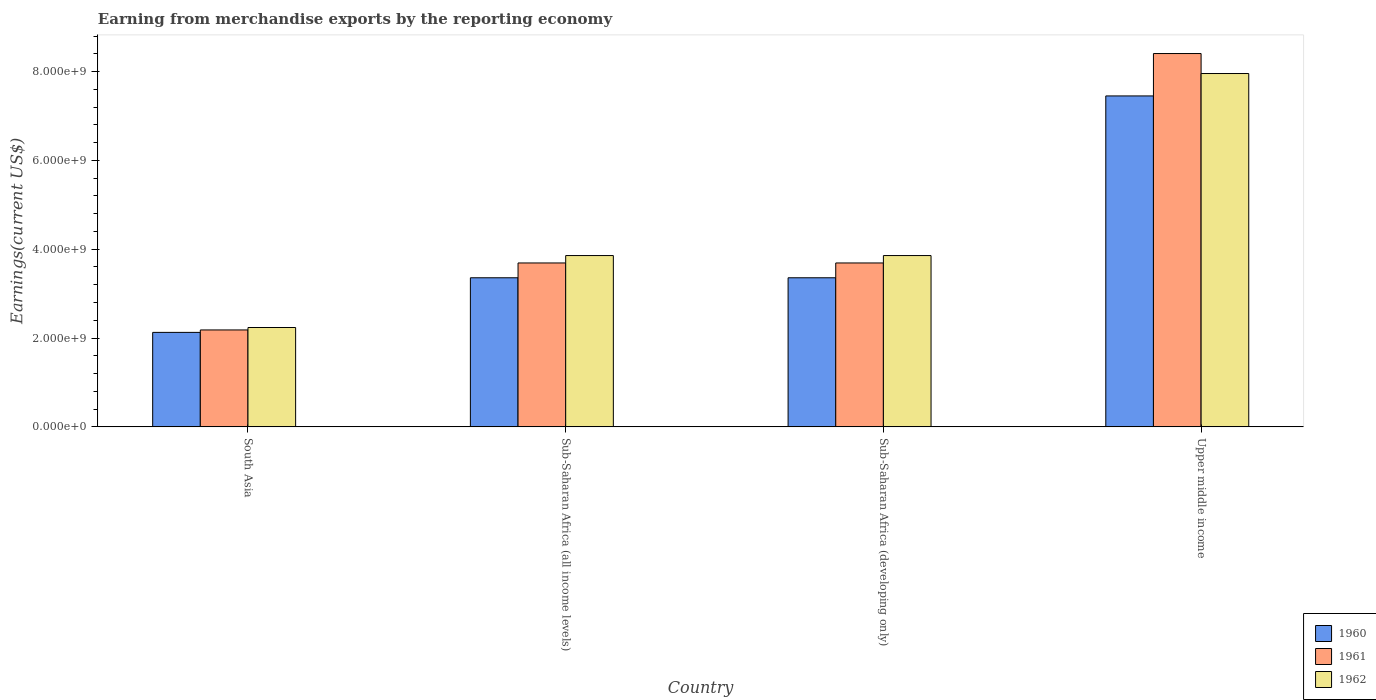How many groups of bars are there?
Give a very brief answer. 4. Are the number of bars per tick equal to the number of legend labels?
Provide a succinct answer. Yes. How many bars are there on the 3rd tick from the right?
Give a very brief answer. 3. What is the label of the 1st group of bars from the left?
Offer a terse response. South Asia. What is the amount earned from merchandise exports in 1960 in South Asia?
Keep it short and to the point. 2.13e+09. Across all countries, what is the maximum amount earned from merchandise exports in 1961?
Keep it short and to the point. 8.41e+09. Across all countries, what is the minimum amount earned from merchandise exports in 1962?
Your response must be concise. 2.24e+09. In which country was the amount earned from merchandise exports in 1962 maximum?
Ensure brevity in your answer.  Upper middle income. In which country was the amount earned from merchandise exports in 1960 minimum?
Ensure brevity in your answer.  South Asia. What is the total amount earned from merchandise exports in 1960 in the graph?
Make the answer very short. 1.63e+1. What is the difference between the amount earned from merchandise exports in 1962 in South Asia and that in Sub-Saharan Africa (developing only)?
Provide a succinct answer. -1.62e+09. What is the difference between the amount earned from merchandise exports in 1962 in Sub-Saharan Africa (developing only) and the amount earned from merchandise exports in 1961 in Upper middle income?
Ensure brevity in your answer.  -4.55e+09. What is the average amount earned from merchandise exports in 1960 per country?
Your answer should be compact. 4.07e+09. What is the difference between the amount earned from merchandise exports of/in 1960 and amount earned from merchandise exports of/in 1961 in South Asia?
Ensure brevity in your answer.  -5.49e+07. In how many countries, is the amount earned from merchandise exports in 1961 greater than 1200000000 US$?
Keep it short and to the point. 4. Is the amount earned from merchandise exports in 1961 in Sub-Saharan Africa (all income levels) less than that in Upper middle income?
Provide a succinct answer. Yes. What is the difference between the highest and the second highest amount earned from merchandise exports in 1962?
Offer a very short reply. 4.10e+09. What is the difference between the highest and the lowest amount earned from merchandise exports in 1961?
Keep it short and to the point. 6.22e+09. What does the 1st bar from the left in South Asia represents?
Offer a very short reply. 1960. How many countries are there in the graph?
Ensure brevity in your answer.  4. Are the values on the major ticks of Y-axis written in scientific E-notation?
Keep it short and to the point. Yes. Does the graph contain any zero values?
Your response must be concise. No. Where does the legend appear in the graph?
Provide a short and direct response. Bottom right. How many legend labels are there?
Offer a very short reply. 3. How are the legend labels stacked?
Offer a very short reply. Vertical. What is the title of the graph?
Offer a terse response. Earning from merchandise exports by the reporting economy. What is the label or title of the Y-axis?
Your response must be concise. Earnings(current US$). What is the Earnings(current US$) in 1960 in South Asia?
Your answer should be very brief. 2.13e+09. What is the Earnings(current US$) of 1961 in South Asia?
Give a very brief answer. 2.18e+09. What is the Earnings(current US$) in 1962 in South Asia?
Your answer should be very brief. 2.24e+09. What is the Earnings(current US$) of 1960 in Sub-Saharan Africa (all income levels)?
Your answer should be compact. 3.36e+09. What is the Earnings(current US$) of 1961 in Sub-Saharan Africa (all income levels)?
Keep it short and to the point. 3.69e+09. What is the Earnings(current US$) in 1962 in Sub-Saharan Africa (all income levels)?
Provide a short and direct response. 3.86e+09. What is the Earnings(current US$) of 1960 in Sub-Saharan Africa (developing only)?
Keep it short and to the point. 3.36e+09. What is the Earnings(current US$) in 1961 in Sub-Saharan Africa (developing only)?
Your answer should be compact. 3.69e+09. What is the Earnings(current US$) of 1962 in Sub-Saharan Africa (developing only)?
Offer a very short reply. 3.86e+09. What is the Earnings(current US$) of 1960 in Upper middle income?
Your answer should be very brief. 7.45e+09. What is the Earnings(current US$) of 1961 in Upper middle income?
Give a very brief answer. 8.41e+09. What is the Earnings(current US$) in 1962 in Upper middle income?
Make the answer very short. 7.96e+09. Across all countries, what is the maximum Earnings(current US$) of 1960?
Make the answer very short. 7.45e+09. Across all countries, what is the maximum Earnings(current US$) in 1961?
Your answer should be compact. 8.41e+09. Across all countries, what is the maximum Earnings(current US$) in 1962?
Offer a very short reply. 7.96e+09. Across all countries, what is the minimum Earnings(current US$) in 1960?
Offer a very short reply. 2.13e+09. Across all countries, what is the minimum Earnings(current US$) of 1961?
Ensure brevity in your answer.  2.18e+09. Across all countries, what is the minimum Earnings(current US$) of 1962?
Give a very brief answer. 2.24e+09. What is the total Earnings(current US$) of 1960 in the graph?
Provide a succinct answer. 1.63e+1. What is the total Earnings(current US$) of 1961 in the graph?
Provide a short and direct response. 1.80e+1. What is the total Earnings(current US$) in 1962 in the graph?
Provide a succinct answer. 1.79e+1. What is the difference between the Earnings(current US$) in 1960 in South Asia and that in Sub-Saharan Africa (all income levels)?
Your response must be concise. -1.23e+09. What is the difference between the Earnings(current US$) in 1961 in South Asia and that in Sub-Saharan Africa (all income levels)?
Provide a short and direct response. -1.51e+09. What is the difference between the Earnings(current US$) in 1962 in South Asia and that in Sub-Saharan Africa (all income levels)?
Offer a very short reply. -1.62e+09. What is the difference between the Earnings(current US$) of 1960 in South Asia and that in Sub-Saharan Africa (developing only)?
Provide a short and direct response. -1.23e+09. What is the difference between the Earnings(current US$) in 1961 in South Asia and that in Sub-Saharan Africa (developing only)?
Offer a very short reply. -1.51e+09. What is the difference between the Earnings(current US$) in 1962 in South Asia and that in Sub-Saharan Africa (developing only)?
Your answer should be compact. -1.62e+09. What is the difference between the Earnings(current US$) of 1960 in South Asia and that in Upper middle income?
Your answer should be compact. -5.32e+09. What is the difference between the Earnings(current US$) in 1961 in South Asia and that in Upper middle income?
Keep it short and to the point. -6.22e+09. What is the difference between the Earnings(current US$) in 1962 in South Asia and that in Upper middle income?
Provide a short and direct response. -5.72e+09. What is the difference between the Earnings(current US$) of 1961 in Sub-Saharan Africa (all income levels) and that in Sub-Saharan Africa (developing only)?
Ensure brevity in your answer.  0. What is the difference between the Earnings(current US$) in 1960 in Sub-Saharan Africa (all income levels) and that in Upper middle income?
Keep it short and to the point. -4.09e+09. What is the difference between the Earnings(current US$) in 1961 in Sub-Saharan Africa (all income levels) and that in Upper middle income?
Offer a terse response. -4.72e+09. What is the difference between the Earnings(current US$) of 1962 in Sub-Saharan Africa (all income levels) and that in Upper middle income?
Your response must be concise. -4.10e+09. What is the difference between the Earnings(current US$) of 1960 in Sub-Saharan Africa (developing only) and that in Upper middle income?
Ensure brevity in your answer.  -4.09e+09. What is the difference between the Earnings(current US$) of 1961 in Sub-Saharan Africa (developing only) and that in Upper middle income?
Make the answer very short. -4.72e+09. What is the difference between the Earnings(current US$) in 1962 in Sub-Saharan Africa (developing only) and that in Upper middle income?
Your answer should be compact. -4.10e+09. What is the difference between the Earnings(current US$) of 1960 in South Asia and the Earnings(current US$) of 1961 in Sub-Saharan Africa (all income levels)?
Provide a short and direct response. -1.56e+09. What is the difference between the Earnings(current US$) of 1960 in South Asia and the Earnings(current US$) of 1962 in Sub-Saharan Africa (all income levels)?
Your answer should be compact. -1.73e+09. What is the difference between the Earnings(current US$) in 1961 in South Asia and the Earnings(current US$) in 1962 in Sub-Saharan Africa (all income levels)?
Your answer should be very brief. -1.67e+09. What is the difference between the Earnings(current US$) of 1960 in South Asia and the Earnings(current US$) of 1961 in Sub-Saharan Africa (developing only)?
Your response must be concise. -1.56e+09. What is the difference between the Earnings(current US$) of 1960 in South Asia and the Earnings(current US$) of 1962 in Sub-Saharan Africa (developing only)?
Provide a succinct answer. -1.73e+09. What is the difference between the Earnings(current US$) in 1961 in South Asia and the Earnings(current US$) in 1962 in Sub-Saharan Africa (developing only)?
Your answer should be compact. -1.67e+09. What is the difference between the Earnings(current US$) of 1960 in South Asia and the Earnings(current US$) of 1961 in Upper middle income?
Give a very brief answer. -6.28e+09. What is the difference between the Earnings(current US$) in 1960 in South Asia and the Earnings(current US$) in 1962 in Upper middle income?
Your answer should be compact. -5.83e+09. What is the difference between the Earnings(current US$) of 1961 in South Asia and the Earnings(current US$) of 1962 in Upper middle income?
Your response must be concise. -5.77e+09. What is the difference between the Earnings(current US$) in 1960 in Sub-Saharan Africa (all income levels) and the Earnings(current US$) in 1961 in Sub-Saharan Africa (developing only)?
Give a very brief answer. -3.33e+08. What is the difference between the Earnings(current US$) in 1960 in Sub-Saharan Africa (all income levels) and the Earnings(current US$) in 1962 in Sub-Saharan Africa (developing only)?
Provide a succinct answer. -5.00e+08. What is the difference between the Earnings(current US$) in 1961 in Sub-Saharan Africa (all income levels) and the Earnings(current US$) in 1962 in Sub-Saharan Africa (developing only)?
Provide a succinct answer. -1.67e+08. What is the difference between the Earnings(current US$) of 1960 in Sub-Saharan Africa (all income levels) and the Earnings(current US$) of 1961 in Upper middle income?
Keep it short and to the point. -5.05e+09. What is the difference between the Earnings(current US$) of 1960 in Sub-Saharan Africa (all income levels) and the Earnings(current US$) of 1962 in Upper middle income?
Keep it short and to the point. -4.60e+09. What is the difference between the Earnings(current US$) of 1961 in Sub-Saharan Africa (all income levels) and the Earnings(current US$) of 1962 in Upper middle income?
Offer a terse response. -4.27e+09. What is the difference between the Earnings(current US$) in 1960 in Sub-Saharan Africa (developing only) and the Earnings(current US$) in 1961 in Upper middle income?
Offer a very short reply. -5.05e+09. What is the difference between the Earnings(current US$) in 1960 in Sub-Saharan Africa (developing only) and the Earnings(current US$) in 1962 in Upper middle income?
Ensure brevity in your answer.  -4.60e+09. What is the difference between the Earnings(current US$) in 1961 in Sub-Saharan Africa (developing only) and the Earnings(current US$) in 1962 in Upper middle income?
Your response must be concise. -4.27e+09. What is the average Earnings(current US$) of 1960 per country?
Give a very brief answer. 4.07e+09. What is the average Earnings(current US$) in 1961 per country?
Your answer should be very brief. 4.49e+09. What is the average Earnings(current US$) of 1962 per country?
Your answer should be very brief. 4.48e+09. What is the difference between the Earnings(current US$) of 1960 and Earnings(current US$) of 1961 in South Asia?
Your answer should be compact. -5.49e+07. What is the difference between the Earnings(current US$) of 1960 and Earnings(current US$) of 1962 in South Asia?
Ensure brevity in your answer.  -1.10e+08. What is the difference between the Earnings(current US$) of 1961 and Earnings(current US$) of 1962 in South Asia?
Offer a very short reply. -5.48e+07. What is the difference between the Earnings(current US$) in 1960 and Earnings(current US$) in 1961 in Sub-Saharan Africa (all income levels)?
Make the answer very short. -3.33e+08. What is the difference between the Earnings(current US$) in 1960 and Earnings(current US$) in 1962 in Sub-Saharan Africa (all income levels)?
Keep it short and to the point. -5.00e+08. What is the difference between the Earnings(current US$) in 1961 and Earnings(current US$) in 1962 in Sub-Saharan Africa (all income levels)?
Ensure brevity in your answer.  -1.67e+08. What is the difference between the Earnings(current US$) of 1960 and Earnings(current US$) of 1961 in Sub-Saharan Africa (developing only)?
Keep it short and to the point. -3.33e+08. What is the difference between the Earnings(current US$) of 1960 and Earnings(current US$) of 1962 in Sub-Saharan Africa (developing only)?
Provide a short and direct response. -5.00e+08. What is the difference between the Earnings(current US$) of 1961 and Earnings(current US$) of 1962 in Sub-Saharan Africa (developing only)?
Your answer should be very brief. -1.67e+08. What is the difference between the Earnings(current US$) of 1960 and Earnings(current US$) of 1961 in Upper middle income?
Your answer should be very brief. -9.55e+08. What is the difference between the Earnings(current US$) in 1960 and Earnings(current US$) in 1962 in Upper middle income?
Offer a terse response. -5.05e+08. What is the difference between the Earnings(current US$) in 1961 and Earnings(current US$) in 1962 in Upper middle income?
Offer a terse response. 4.50e+08. What is the ratio of the Earnings(current US$) in 1960 in South Asia to that in Sub-Saharan Africa (all income levels)?
Your answer should be very brief. 0.63. What is the ratio of the Earnings(current US$) in 1961 in South Asia to that in Sub-Saharan Africa (all income levels)?
Your response must be concise. 0.59. What is the ratio of the Earnings(current US$) in 1962 in South Asia to that in Sub-Saharan Africa (all income levels)?
Keep it short and to the point. 0.58. What is the ratio of the Earnings(current US$) in 1960 in South Asia to that in Sub-Saharan Africa (developing only)?
Your answer should be very brief. 0.63. What is the ratio of the Earnings(current US$) of 1961 in South Asia to that in Sub-Saharan Africa (developing only)?
Give a very brief answer. 0.59. What is the ratio of the Earnings(current US$) in 1962 in South Asia to that in Sub-Saharan Africa (developing only)?
Provide a succinct answer. 0.58. What is the ratio of the Earnings(current US$) in 1960 in South Asia to that in Upper middle income?
Keep it short and to the point. 0.29. What is the ratio of the Earnings(current US$) in 1961 in South Asia to that in Upper middle income?
Keep it short and to the point. 0.26. What is the ratio of the Earnings(current US$) in 1962 in South Asia to that in Upper middle income?
Offer a very short reply. 0.28. What is the ratio of the Earnings(current US$) of 1960 in Sub-Saharan Africa (all income levels) to that in Sub-Saharan Africa (developing only)?
Provide a succinct answer. 1. What is the ratio of the Earnings(current US$) in 1961 in Sub-Saharan Africa (all income levels) to that in Sub-Saharan Africa (developing only)?
Provide a short and direct response. 1. What is the ratio of the Earnings(current US$) in 1962 in Sub-Saharan Africa (all income levels) to that in Sub-Saharan Africa (developing only)?
Keep it short and to the point. 1. What is the ratio of the Earnings(current US$) of 1960 in Sub-Saharan Africa (all income levels) to that in Upper middle income?
Your answer should be very brief. 0.45. What is the ratio of the Earnings(current US$) in 1961 in Sub-Saharan Africa (all income levels) to that in Upper middle income?
Provide a short and direct response. 0.44. What is the ratio of the Earnings(current US$) of 1962 in Sub-Saharan Africa (all income levels) to that in Upper middle income?
Ensure brevity in your answer.  0.48. What is the ratio of the Earnings(current US$) in 1960 in Sub-Saharan Africa (developing only) to that in Upper middle income?
Keep it short and to the point. 0.45. What is the ratio of the Earnings(current US$) of 1961 in Sub-Saharan Africa (developing only) to that in Upper middle income?
Provide a short and direct response. 0.44. What is the ratio of the Earnings(current US$) of 1962 in Sub-Saharan Africa (developing only) to that in Upper middle income?
Offer a terse response. 0.48. What is the difference between the highest and the second highest Earnings(current US$) in 1960?
Your response must be concise. 4.09e+09. What is the difference between the highest and the second highest Earnings(current US$) in 1961?
Give a very brief answer. 4.72e+09. What is the difference between the highest and the second highest Earnings(current US$) of 1962?
Your response must be concise. 4.10e+09. What is the difference between the highest and the lowest Earnings(current US$) of 1960?
Provide a short and direct response. 5.32e+09. What is the difference between the highest and the lowest Earnings(current US$) in 1961?
Your response must be concise. 6.22e+09. What is the difference between the highest and the lowest Earnings(current US$) in 1962?
Your answer should be compact. 5.72e+09. 